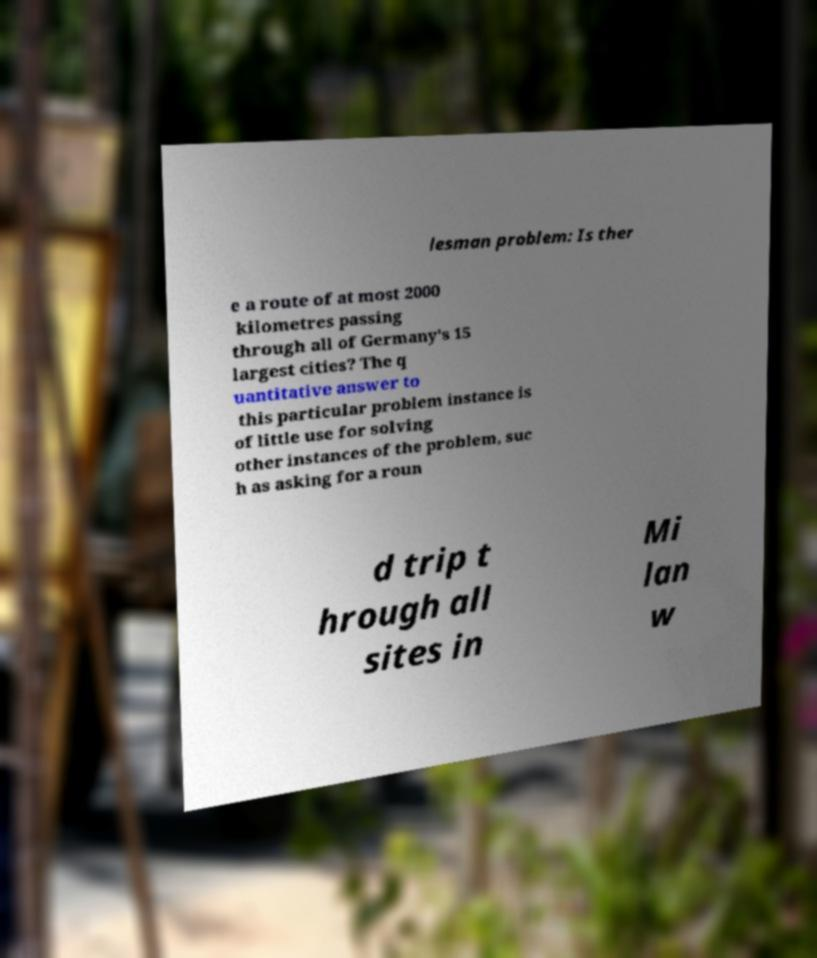Please identify and transcribe the text found in this image. lesman problem: Is ther e a route of at most 2000 kilometres passing through all of Germany's 15 largest cities? The q uantitative answer to this particular problem instance is of little use for solving other instances of the problem, suc h as asking for a roun d trip t hrough all sites in Mi lan w 